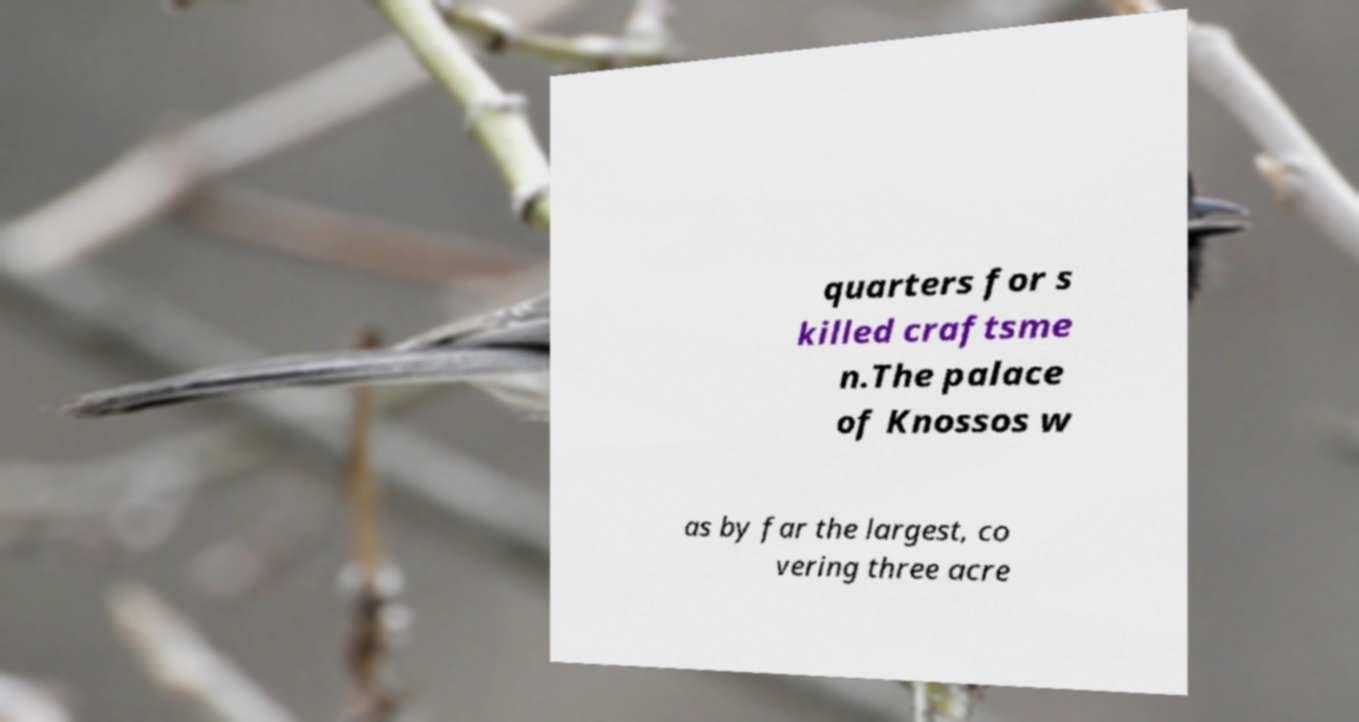There's text embedded in this image that I need extracted. Can you transcribe it verbatim? quarters for s killed craftsme n.The palace of Knossos w as by far the largest, co vering three acre 